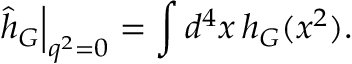Convert formula to latex. <formula><loc_0><loc_0><loc_500><loc_500>\hat { h } _ { G } \right | _ { q ^ { 2 } = 0 } = \int d ^ { 4 } x \, h _ { G } ( x ^ { 2 } ) .</formula> 